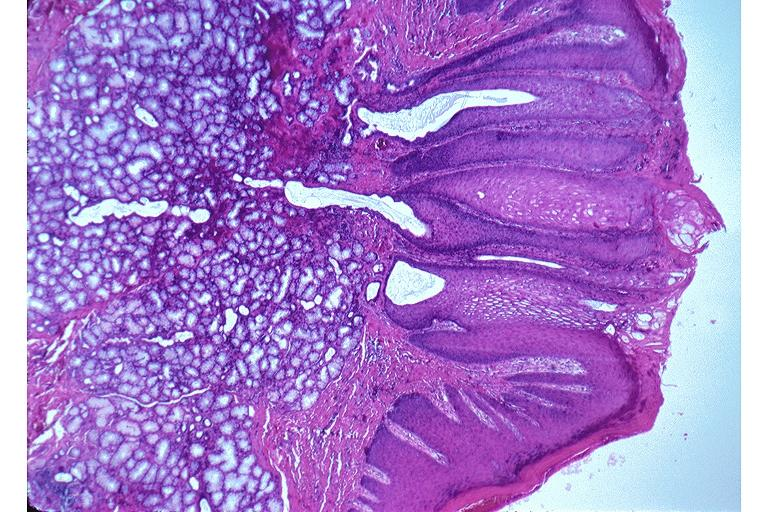where is this?
Answer the question using a single word or phrase. Oral 